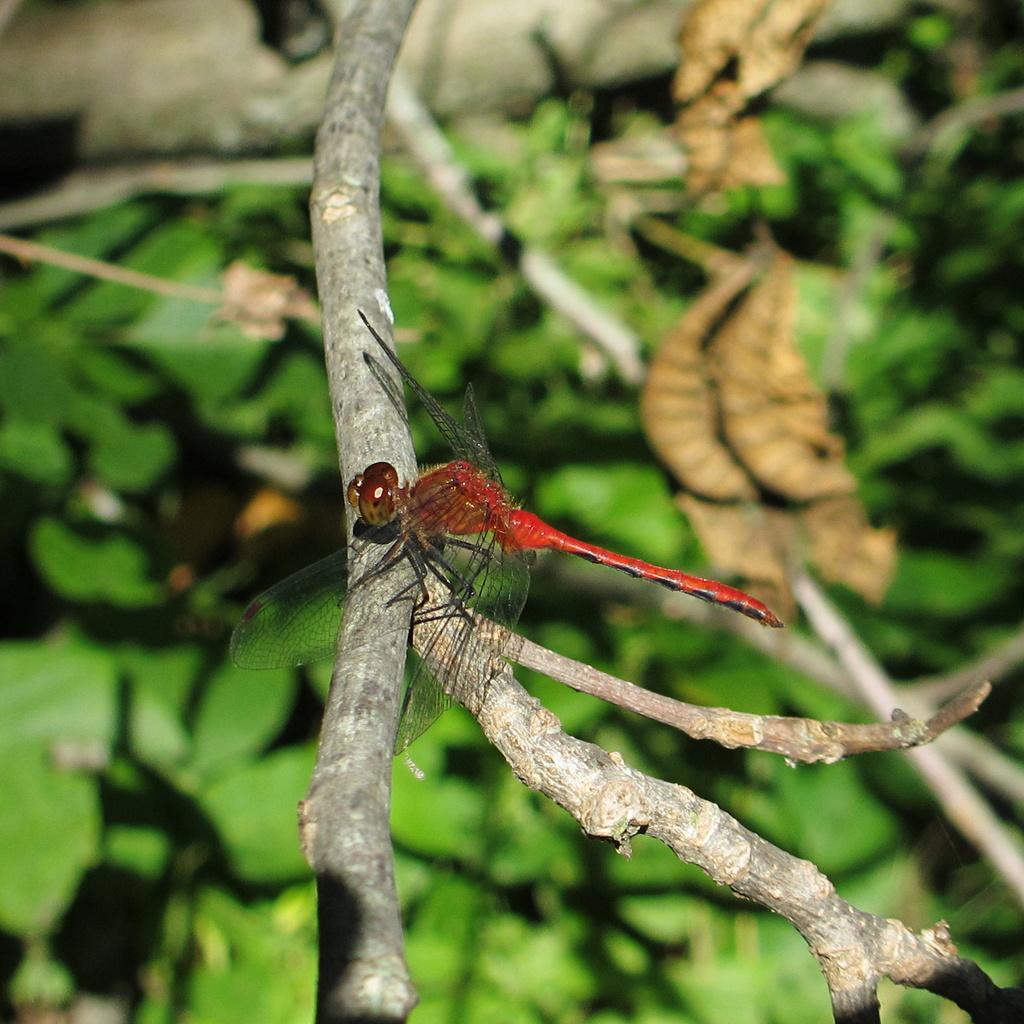Please provide a concise description of this image. In the center of the image, we can see a house fly on the stem and in the background, there are leaves. 